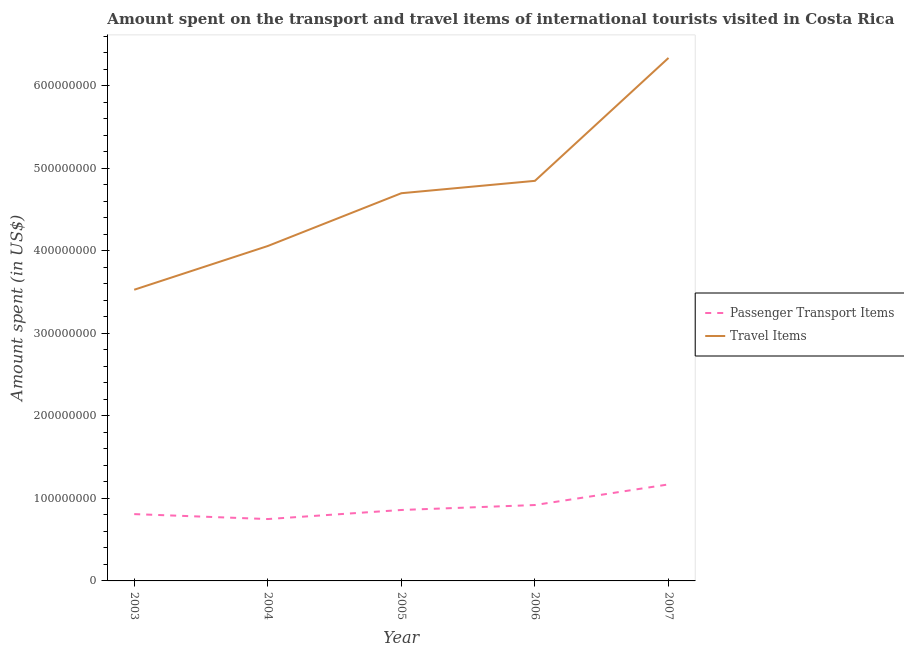How many different coloured lines are there?
Your response must be concise. 2. Is the number of lines equal to the number of legend labels?
Your answer should be very brief. Yes. What is the amount spent in travel items in 2004?
Make the answer very short. 4.06e+08. Across all years, what is the maximum amount spent on passenger transport items?
Your answer should be very brief. 1.17e+08. Across all years, what is the minimum amount spent on passenger transport items?
Provide a short and direct response. 7.50e+07. In which year was the amount spent in travel items maximum?
Keep it short and to the point. 2007. In which year was the amount spent in travel items minimum?
Offer a terse response. 2003. What is the total amount spent in travel items in the graph?
Keep it short and to the point. 2.35e+09. What is the difference between the amount spent on passenger transport items in 2003 and that in 2005?
Provide a short and direct response. -5.00e+06. What is the difference between the amount spent in travel items in 2003 and the amount spent on passenger transport items in 2005?
Your answer should be compact. 2.67e+08. What is the average amount spent on passenger transport items per year?
Provide a succinct answer. 9.02e+07. In the year 2005, what is the difference between the amount spent on passenger transport items and amount spent in travel items?
Keep it short and to the point. -3.84e+08. In how many years, is the amount spent on passenger transport items greater than 440000000 US$?
Make the answer very short. 0. What is the ratio of the amount spent on passenger transport items in 2004 to that in 2007?
Your answer should be compact. 0.64. Is the amount spent on passenger transport items in 2003 less than that in 2006?
Ensure brevity in your answer.  Yes. What is the difference between the highest and the second highest amount spent on passenger transport items?
Offer a very short reply. 2.50e+07. What is the difference between the highest and the lowest amount spent in travel items?
Give a very brief answer. 2.81e+08. Does the amount spent on passenger transport items monotonically increase over the years?
Give a very brief answer. No. What is the difference between two consecutive major ticks on the Y-axis?
Provide a short and direct response. 1.00e+08. Where does the legend appear in the graph?
Make the answer very short. Center right. How many legend labels are there?
Ensure brevity in your answer.  2. How are the legend labels stacked?
Your answer should be compact. Vertical. What is the title of the graph?
Keep it short and to the point. Amount spent on the transport and travel items of international tourists visited in Costa Rica. What is the label or title of the X-axis?
Give a very brief answer. Year. What is the label or title of the Y-axis?
Make the answer very short. Amount spent (in US$). What is the Amount spent (in US$) in Passenger Transport Items in 2003?
Give a very brief answer. 8.10e+07. What is the Amount spent (in US$) of Travel Items in 2003?
Your response must be concise. 3.53e+08. What is the Amount spent (in US$) in Passenger Transport Items in 2004?
Ensure brevity in your answer.  7.50e+07. What is the Amount spent (in US$) of Travel Items in 2004?
Keep it short and to the point. 4.06e+08. What is the Amount spent (in US$) in Passenger Transport Items in 2005?
Ensure brevity in your answer.  8.60e+07. What is the Amount spent (in US$) of Travel Items in 2005?
Make the answer very short. 4.70e+08. What is the Amount spent (in US$) of Passenger Transport Items in 2006?
Your answer should be very brief. 9.20e+07. What is the Amount spent (in US$) in Travel Items in 2006?
Make the answer very short. 4.85e+08. What is the Amount spent (in US$) of Passenger Transport Items in 2007?
Give a very brief answer. 1.17e+08. What is the Amount spent (in US$) in Travel Items in 2007?
Provide a short and direct response. 6.34e+08. Across all years, what is the maximum Amount spent (in US$) of Passenger Transport Items?
Ensure brevity in your answer.  1.17e+08. Across all years, what is the maximum Amount spent (in US$) in Travel Items?
Offer a very short reply. 6.34e+08. Across all years, what is the minimum Amount spent (in US$) of Passenger Transport Items?
Give a very brief answer. 7.50e+07. Across all years, what is the minimum Amount spent (in US$) of Travel Items?
Make the answer very short. 3.53e+08. What is the total Amount spent (in US$) of Passenger Transport Items in the graph?
Offer a terse response. 4.51e+08. What is the total Amount spent (in US$) in Travel Items in the graph?
Make the answer very short. 2.35e+09. What is the difference between the Amount spent (in US$) in Passenger Transport Items in 2003 and that in 2004?
Ensure brevity in your answer.  6.00e+06. What is the difference between the Amount spent (in US$) in Travel Items in 2003 and that in 2004?
Offer a very short reply. -5.30e+07. What is the difference between the Amount spent (in US$) in Passenger Transport Items in 2003 and that in 2005?
Your answer should be very brief. -5.00e+06. What is the difference between the Amount spent (in US$) in Travel Items in 2003 and that in 2005?
Keep it short and to the point. -1.17e+08. What is the difference between the Amount spent (in US$) of Passenger Transport Items in 2003 and that in 2006?
Provide a succinct answer. -1.10e+07. What is the difference between the Amount spent (in US$) in Travel Items in 2003 and that in 2006?
Give a very brief answer. -1.32e+08. What is the difference between the Amount spent (in US$) in Passenger Transport Items in 2003 and that in 2007?
Make the answer very short. -3.60e+07. What is the difference between the Amount spent (in US$) in Travel Items in 2003 and that in 2007?
Your answer should be compact. -2.81e+08. What is the difference between the Amount spent (in US$) of Passenger Transport Items in 2004 and that in 2005?
Keep it short and to the point. -1.10e+07. What is the difference between the Amount spent (in US$) of Travel Items in 2004 and that in 2005?
Make the answer very short. -6.40e+07. What is the difference between the Amount spent (in US$) in Passenger Transport Items in 2004 and that in 2006?
Make the answer very short. -1.70e+07. What is the difference between the Amount spent (in US$) of Travel Items in 2004 and that in 2006?
Offer a very short reply. -7.90e+07. What is the difference between the Amount spent (in US$) of Passenger Transport Items in 2004 and that in 2007?
Offer a very short reply. -4.20e+07. What is the difference between the Amount spent (in US$) in Travel Items in 2004 and that in 2007?
Make the answer very short. -2.28e+08. What is the difference between the Amount spent (in US$) in Passenger Transport Items in 2005 and that in 2006?
Ensure brevity in your answer.  -6.00e+06. What is the difference between the Amount spent (in US$) of Travel Items in 2005 and that in 2006?
Keep it short and to the point. -1.50e+07. What is the difference between the Amount spent (in US$) of Passenger Transport Items in 2005 and that in 2007?
Ensure brevity in your answer.  -3.10e+07. What is the difference between the Amount spent (in US$) in Travel Items in 2005 and that in 2007?
Provide a short and direct response. -1.64e+08. What is the difference between the Amount spent (in US$) of Passenger Transport Items in 2006 and that in 2007?
Your answer should be very brief. -2.50e+07. What is the difference between the Amount spent (in US$) of Travel Items in 2006 and that in 2007?
Ensure brevity in your answer.  -1.49e+08. What is the difference between the Amount spent (in US$) in Passenger Transport Items in 2003 and the Amount spent (in US$) in Travel Items in 2004?
Keep it short and to the point. -3.25e+08. What is the difference between the Amount spent (in US$) in Passenger Transport Items in 2003 and the Amount spent (in US$) in Travel Items in 2005?
Provide a succinct answer. -3.89e+08. What is the difference between the Amount spent (in US$) in Passenger Transport Items in 2003 and the Amount spent (in US$) in Travel Items in 2006?
Provide a succinct answer. -4.04e+08. What is the difference between the Amount spent (in US$) of Passenger Transport Items in 2003 and the Amount spent (in US$) of Travel Items in 2007?
Ensure brevity in your answer.  -5.53e+08. What is the difference between the Amount spent (in US$) of Passenger Transport Items in 2004 and the Amount spent (in US$) of Travel Items in 2005?
Your answer should be very brief. -3.95e+08. What is the difference between the Amount spent (in US$) in Passenger Transport Items in 2004 and the Amount spent (in US$) in Travel Items in 2006?
Your answer should be very brief. -4.10e+08. What is the difference between the Amount spent (in US$) of Passenger Transport Items in 2004 and the Amount spent (in US$) of Travel Items in 2007?
Keep it short and to the point. -5.59e+08. What is the difference between the Amount spent (in US$) of Passenger Transport Items in 2005 and the Amount spent (in US$) of Travel Items in 2006?
Make the answer very short. -3.99e+08. What is the difference between the Amount spent (in US$) of Passenger Transport Items in 2005 and the Amount spent (in US$) of Travel Items in 2007?
Your answer should be compact. -5.48e+08. What is the difference between the Amount spent (in US$) in Passenger Transport Items in 2006 and the Amount spent (in US$) in Travel Items in 2007?
Provide a succinct answer. -5.42e+08. What is the average Amount spent (in US$) in Passenger Transport Items per year?
Offer a very short reply. 9.02e+07. What is the average Amount spent (in US$) in Travel Items per year?
Your answer should be compact. 4.70e+08. In the year 2003, what is the difference between the Amount spent (in US$) in Passenger Transport Items and Amount spent (in US$) in Travel Items?
Keep it short and to the point. -2.72e+08. In the year 2004, what is the difference between the Amount spent (in US$) of Passenger Transport Items and Amount spent (in US$) of Travel Items?
Ensure brevity in your answer.  -3.31e+08. In the year 2005, what is the difference between the Amount spent (in US$) of Passenger Transport Items and Amount spent (in US$) of Travel Items?
Your answer should be very brief. -3.84e+08. In the year 2006, what is the difference between the Amount spent (in US$) in Passenger Transport Items and Amount spent (in US$) in Travel Items?
Offer a terse response. -3.93e+08. In the year 2007, what is the difference between the Amount spent (in US$) of Passenger Transport Items and Amount spent (in US$) of Travel Items?
Your answer should be compact. -5.17e+08. What is the ratio of the Amount spent (in US$) in Passenger Transport Items in 2003 to that in 2004?
Ensure brevity in your answer.  1.08. What is the ratio of the Amount spent (in US$) in Travel Items in 2003 to that in 2004?
Provide a succinct answer. 0.87. What is the ratio of the Amount spent (in US$) in Passenger Transport Items in 2003 to that in 2005?
Offer a terse response. 0.94. What is the ratio of the Amount spent (in US$) of Travel Items in 2003 to that in 2005?
Your answer should be very brief. 0.75. What is the ratio of the Amount spent (in US$) in Passenger Transport Items in 2003 to that in 2006?
Your response must be concise. 0.88. What is the ratio of the Amount spent (in US$) of Travel Items in 2003 to that in 2006?
Ensure brevity in your answer.  0.73. What is the ratio of the Amount spent (in US$) of Passenger Transport Items in 2003 to that in 2007?
Your answer should be compact. 0.69. What is the ratio of the Amount spent (in US$) of Travel Items in 2003 to that in 2007?
Your response must be concise. 0.56. What is the ratio of the Amount spent (in US$) of Passenger Transport Items in 2004 to that in 2005?
Your response must be concise. 0.87. What is the ratio of the Amount spent (in US$) of Travel Items in 2004 to that in 2005?
Your answer should be very brief. 0.86. What is the ratio of the Amount spent (in US$) of Passenger Transport Items in 2004 to that in 2006?
Provide a succinct answer. 0.82. What is the ratio of the Amount spent (in US$) of Travel Items in 2004 to that in 2006?
Ensure brevity in your answer.  0.84. What is the ratio of the Amount spent (in US$) in Passenger Transport Items in 2004 to that in 2007?
Your answer should be compact. 0.64. What is the ratio of the Amount spent (in US$) of Travel Items in 2004 to that in 2007?
Your answer should be compact. 0.64. What is the ratio of the Amount spent (in US$) of Passenger Transport Items in 2005 to that in 2006?
Your response must be concise. 0.93. What is the ratio of the Amount spent (in US$) in Travel Items in 2005 to that in 2006?
Provide a succinct answer. 0.97. What is the ratio of the Amount spent (in US$) in Passenger Transport Items in 2005 to that in 2007?
Offer a terse response. 0.73. What is the ratio of the Amount spent (in US$) in Travel Items in 2005 to that in 2007?
Keep it short and to the point. 0.74. What is the ratio of the Amount spent (in US$) of Passenger Transport Items in 2006 to that in 2007?
Offer a very short reply. 0.79. What is the ratio of the Amount spent (in US$) of Travel Items in 2006 to that in 2007?
Provide a short and direct response. 0.77. What is the difference between the highest and the second highest Amount spent (in US$) of Passenger Transport Items?
Offer a very short reply. 2.50e+07. What is the difference between the highest and the second highest Amount spent (in US$) of Travel Items?
Ensure brevity in your answer.  1.49e+08. What is the difference between the highest and the lowest Amount spent (in US$) of Passenger Transport Items?
Provide a succinct answer. 4.20e+07. What is the difference between the highest and the lowest Amount spent (in US$) in Travel Items?
Your answer should be very brief. 2.81e+08. 